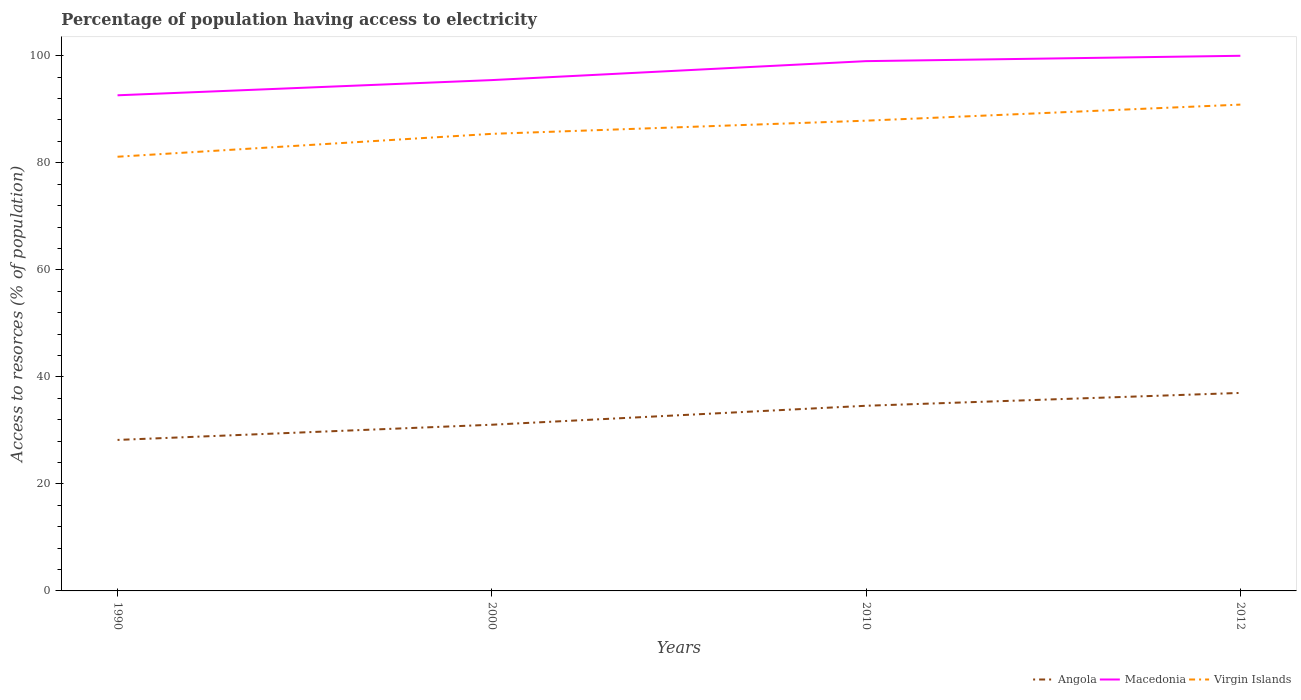How many different coloured lines are there?
Ensure brevity in your answer.  3. Does the line corresponding to Macedonia intersect with the line corresponding to Virgin Islands?
Provide a succinct answer. No. Across all years, what is the maximum percentage of population having access to electricity in Angola?
Your answer should be compact. 28.22. In which year was the percentage of population having access to electricity in Angola maximum?
Your response must be concise. 1990. What is the total percentage of population having access to electricity in Angola in the graph?
Offer a very short reply. -6.38. What is the difference between the highest and the second highest percentage of population having access to electricity in Virgin Islands?
Provide a succinct answer. 9.74. What is the difference between the highest and the lowest percentage of population having access to electricity in Macedonia?
Give a very brief answer. 2. Is the percentage of population having access to electricity in Angola strictly greater than the percentage of population having access to electricity in Macedonia over the years?
Keep it short and to the point. Yes. What is the difference between two consecutive major ticks on the Y-axis?
Keep it short and to the point. 20. Are the values on the major ticks of Y-axis written in scientific E-notation?
Offer a very short reply. No. Does the graph contain grids?
Your response must be concise. No. Where does the legend appear in the graph?
Provide a succinct answer. Bottom right. How many legend labels are there?
Offer a terse response. 3. What is the title of the graph?
Provide a succinct answer. Percentage of population having access to electricity. Does "Portugal" appear as one of the legend labels in the graph?
Offer a terse response. No. What is the label or title of the Y-axis?
Your answer should be very brief. Access to resorces (% of population). What is the Access to resorces (% of population) of Angola in 1990?
Offer a very short reply. 28.22. What is the Access to resorces (% of population) in Macedonia in 1990?
Offer a very short reply. 92.62. What is the Access to resorces (% of population) in Virgin Islands in 1990?
Ensure brevity in your answer.  81.14. What is the Access to resorces (% of population) of Angola in 2000?
Give a very brief answer. 31.06. What is the Access to resorces (% of population) of Macedonia in 2000?
Offer a terse response. 95.46. What is the Access to resorces (% of population) in Virgin Islands in 2000?
Keep it short and to the point. 85.41. What is the Access to resorces (% of population) in Angola in 2010?
Your answer should be compact. 34.6. What is the Access to resorces (% of population) in Macedonia in 2010?
Ensure brevity in your answer.  99. What is the Access to resorces (% of population) in Virgin Islands in 2010?
Provide a short and direct response. 87.87. What is the Access to resorces (% of population) of Angola in 2012?
Your answer should be compact. 37. What is the Access to resorces (% of population) of Virgin Islands in 2012?
Keep it short and to the point. 90.88. Across all years, what is the maximum Access to resorces (% of population) of Angola?
Your response must be concise. 37. Across all years, what is the maximum Access to resorces (% of population) in Virgin Islands?
Ensure brevity in your answer.  90.88. Across all years, what is the minimum Access to resorces (% of population) of Angola?
Your response must be concise. 28.22. Across all years, what is the minimum Access to resorces (% of population) in Macedonia?
Your response must be concise. 92.62. Across all years, what is the minimum Access to resorces (% of population) in Virgin Islands?
Provide a short and direct response. 81.14. What is the total Access to resorces (% of population) of Angola in the graph?
Make the answer very short. 130.87. What is the total Access to resorces (% of population) in Macedonia in the graph?
Keep it short and to the point. 387.07. What is the total Access to resorces (% of population) in Virgin Islands in the graph?
Make the answer very short. 345.3. What is the difference between the Access to resorces (% of population) in Angola in 1990 and that in 2000?
Ensure brevity in your answer.  -2.84. What is the difference between the Access to resorces (% of population) in Macedonia in 1990 and that in 2000?
Your answer should be very brief. -2.84. What is the difference between the Access to resorces (% of population) in Virgin Islands in 1990 and that in 2000?
Keep it short and to the point. -4.28. What is the difference between the Access to resorces (% of population) of Angola in 1990 and that in 2010?
Give a very brief answer. -6.38. What is the difference between the Access to resorces (% of population) of Macedonia in 1990 and that in 2010?
Make the answer very short. -6.38. What is the difference between the Access to resorces (% of population) of Virgin Islands in 1990 and that in 2010?
Ensure brevity in your answer.  -6.74. What is the difference between the Access to resorces (% of population) of Angola in 1990 and that in 2012?
Keep it short and to the point. -8.78. What is the difference between the Access to resorces (% of population) of Macedonia in 1990 and that in 2012?
Provide a short and direct response. -7.38. What is the difference between the Access to resorces (% of population) in Virgin Islands in 1990 and that in 2012?
Your response must be concise. -9.74. What is the difference between the Access to resorces (% of population) of Angola in 2000 and that in 2010?
Ensure brevity in your answer.  -3.54. What is the difference between the Access to resorces (% of population) of Macedonia in 2000 and that in 2010?
Ensure brevity in your answer.  -3.54. What is the difference between the Access to resorces (% of population) of Virgin Islands in 2000 and that in 2010?
Make the answer very short. -2.46. What is the difference between the Access to resorces (% of population) of Angola in 2000 and that in 2012?
Ensure brevity in your answer.  -5.94. What is the difference between the Access to resorces (% of population) of Macedonia in 2000 and that in 2012?
Your answer should be very brief. -4.54. What is the difference between the Access to resorces (% of population) in Virgin Islands in 2000 and that in 2012?
Make the answer very short. -5.46. What is the difference between the Access to resorces (% of population) in Angola in 2010 and that in 2012?
Make the answer very short. -2.4. What is the difference between the Access to resorces (% of population) of Virgin Islands in 2010 and that in 2012?
Your response must be concise. -3. What is the difference between the Access to resorces (% of population) of Angola in 1990 and the Access to resorces (% of population) of Macedonia in 2000?
Ensure brevity in your answer.  -67.24. What is the difference between the Access to resorces (% of population) in Angola in 1990 and the Access to resorces (% of population) in Virgin Islands in 2000?
Give a very brief answer. -57.2. What is the difference between the Access to resorces (% of population) in Macedonia in 1990 and the Access to resorces (% of population) in Virgin Islands in 2000?
Your response must be concise. 7.2. What is the difference between the Access to resorces (% of population) of Angola in 1990 and the Access to resorces (% of population) of Macedonia in 2010?
Your answer should be very brief. -70.78. What is the difference between the Access to resorces (% of population) of Angola in 1990 and the Access to resorces (% of population) of Virgin Islands in 2010?
Offer a terse response. -59.66. What is the difference between the Access to resorces (% of population) in Macedonia in 1990 and the Access to resorces (% of population) in Virgin Islands in 2010?
Keep it short and to the point. 4.74. What is the difference between the Access to resorces (% of population) in Angola in 1990 and the Access to resorces (% of population) in Macedonia in 2012?
Your answer should be compact. -71.78. What is the difference between the Access to resorces (% of population) of Angola in 1990 and the Access to resorces (% of population) of Virgin Islands in 2012?
Provide a short and direct response. -62.66. What is the difference between the Access to resorces (% of population) in Macedonia in 1990 and the Access to resorces (% of population) in Virgin Islands in 2012?
Offer a very short reply. 1.74. What is the difference between the Access to resorces (% of population) in Angola in 2000 and the Access to resorces (% of population) in Macedonia in 2010?
Your response must be concise. -67.94. What is the difference between the Access to resorces (% of population) of Angola in 2000 and the Access to resorces (% of population) of Virgin Islands in 2010?
Your answer should be compact. -56.82. What is the difference between the Access to resorces (% of population) of Macedonia in 2000 and the Access to resorces (% of population) of Virgin Islands in 2010?
Ensure brevity in your answer.  7.58. What is the difference between the Access to resorces (% of population) in Angola in 2000 and the Access to resorces (% of population) in Macedonia in 2012?
Offer a terse response. -68.94. What is the difference between the Access to resorces (% of population) of Angola in 2000 and the Access to resorces (% of population) of Virgin Islands in 2012?
Make the answer very short. -59.82. What is the difference between the Access to resorces (% of population) of Macedonia in 2000 and the Access to resorces (% of population) of Virgin Islands in 2012?
Provide a short and direct response. 4.58. What is the difference between the Access to resorces (% of population) in Angola in 2010 and the Access to resorces (% of population) in Macedonia in 2012?
Keep it short and to the point. -65.4. What is the difference between the Access to resorces (% of population) in Angola in 2010 and the Access to resorces (% of population) in Virgin Islands in 2012?
Make the answer very short. -56.28. What is the difference between the Access to resorces (% of population) in Macedonia in 2010 and the Access to resorces (% of population) in Virgin Islands in 2012?
Your answer should be very brief. 8.12. What is the average Access to resorces (% of population) in Angola per year?
Your response must be concise. 32.72. What is the average Access to resorces (% of population) in Macedonia per year?
Make the answer very short. 96.77. What is the average Access to resorces (% of population) in Virgin Islands per year?
Make the answer very short. 86.32. In the year 1990, what is the difference between the Access to resorces (% of population) in Angola and Access to resorces (% of population) in Macedonia?
Provide a short and direct response. -64.4. In the year 1990, what is the difference between the Access to resorces (% of population) of Angola and Access to resorces (% of population) of Virgin Islands?
Ensure brevity in your answer.  -52.92. In the year 1990, what is the difference between the Access to resorces (% of population) in Macedonia and Access to resorces (% of population) in Virgin Islands?
Your answer should be very brief. 11.48. In the year 2000, what is the difference between the Access to resorces (% of population) in Angola and Access to resorces (% of population) in Macedonia?
Your response must be concise. -64.4. In the year 2000, what is the difference between the Access to resorces (% of population) of Angola and Access to resorces (% of population) of Virgin Islands?
Keep it short and to the point. -54.36. In the year 2000, what is the difference between the Access to resorces (% of population) of Macedonia and Access to resorces (% of population) of Virgin Islands?
Make the answer very short. 10.04. In the year 2010, what is the difference between the Access to resorces (% of population) in Angola and Access to resorces (% of population) in Macedonia?
Your answer should be compact. -64.4. In the year 2010, what is the difference between the Access to resorces (% of population) in Angola and Access to resorces (% of population) in Virgin Islands?
Your response must be concise. -53.27. In the year 2010, what is the difference between the Access to resorces (% of population) of Macedonia and Access to resorces (% of population) of Virgin Islands?
Offer a terse response. 11.13. In the year 2012, what is the difference between the Access to resorces (% of population) of Angola and Access to resorces (% of population) of Macedonia?
Your response must be concise. -63. In the year 2012, what is the difference between the Access to resorces (% of population) in Angola and Access to resorces (% of population) in Virgin Islands?
Your answer should be very brief. -53.88. In the year 2012, what is the difference between the Access to resorces (% of population) of Macedonia and Access to resorces (% of population) of Virgin Islands?
Your answer should be very brief. 9.12. What is the ratio of the Access to resorces (% of population) in Angola in 1990 to that in 2000?
Offer a very short reply. 0.91. What is the ratio of the Access to resorces (% of population) of Macedonia in 1990 to that in 2000?
Your answer should be very brief. 0.97. What is the ratio of the Access to resorces (% of population) in Virgin Islands in 1990 to that in 2000?
Keep it short and to the point. 0.95. What is the ratio of the Access to resorces (% of population) in Angola in 1990 to that in 2010?
Make the answer very short. 0.82. What is the ratio of the Access to resorces (% of population) in Macedonia in 1990 to that in 2010?
Your answer should be compact. 0.94. What is the ratio of the Access to resorces (% of population) in Virgin Islands in 1990 to that in 2010?
Your answer should be compact. 0.92. What is the ratio of the Access to resorces (% of population) of Angola in 1990 to that in 2012?
Your answer should be compact. 0.76. What is the ratio of the Access to resorces (% of population) in Macedonia in 1990 to that in 2012?
Make the answer very short. 0.93. What is the ratio of the Access to resorces (% of population) in Virgin Islands in 1990 to that in 2012?
Ensure brevity in your answer.  0.89. What is the ratio of the Access to resorces (% of population) of Angola in 2000 to that in 2010?
Provide a short and direct response. 0.9. What is the ratio of the Access to resorces (% of population) of Macedonia in 2000 to that in 2010?
Give a very brief answer. 0.96. What is the ratio of the Access to resorces (% of population) of Angola in 2000 to that in 2012?
Your answer should be very brief. 0.84. What is the ratio of the Access to resorces (% of population) in Macedonia in 2000 to that in 2012?
Keep it short and to the point. 0.95. What is the ratio of the Access to resorces (% of population) in Virgin Islands in 2000 to that in 2012?
Provide a succinct answer. 0.94. What is the ratio of the Access to resorces (% of population) of Angola in 2010 to that in 2012?
Your answer should be compact. 0.94. What is the difference between the highest and the second highest Access to resorces (% of population) of Angola?
Ensure brevity in your answer.  2.4. What is the difference between the highest and the second highest Access to resorces (% of population) of Virgin Islands?
Your response must be concise. 3. What is the difference between the highest and the lowest Access to resorces (% of population) of Angola?
Give a very brief answer. 8.78. What is the difference between the highest and the lowest Access to resorces (% of population) in Macedonia?
Give a very brief answer. 7.38. What is the difference between the highest and the lowest Access to resorces (% of population) of Virgin Islands?
Keep it short and to the point. 9.74. 